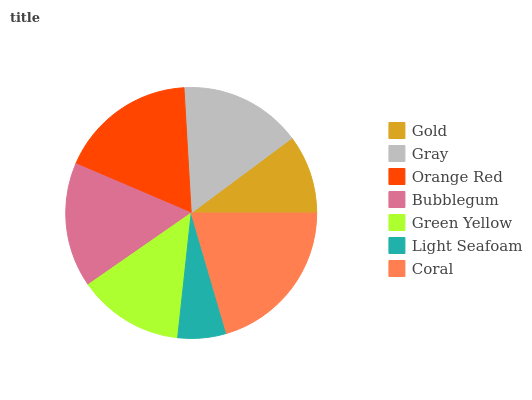Is Light Seafoam the minimum?
Answer yes or no. Yes. Is Coral the maximum?
Answer yes or no. Yes. Is Gray the minimum?
Answer yes or no. No. Is Gray the maximum?
Answer yes or no. No. Is Gray greater than Gold?
Answer yes or no. Yes. Is Gold less than Gray?
Answer yes or no. Yes. Is Gold greater than Gray?
Answer yes or no. No. Is Gray less than Gold?
Answer yes or no. No. Is Gray the high median?
Answer yes or no. Yes. Is Gray the low median?
Answer yes or no. Yes. Is Coral the high median?
Answer yes or no. No. Is Coral the low median?
Answer yes or no. No. 